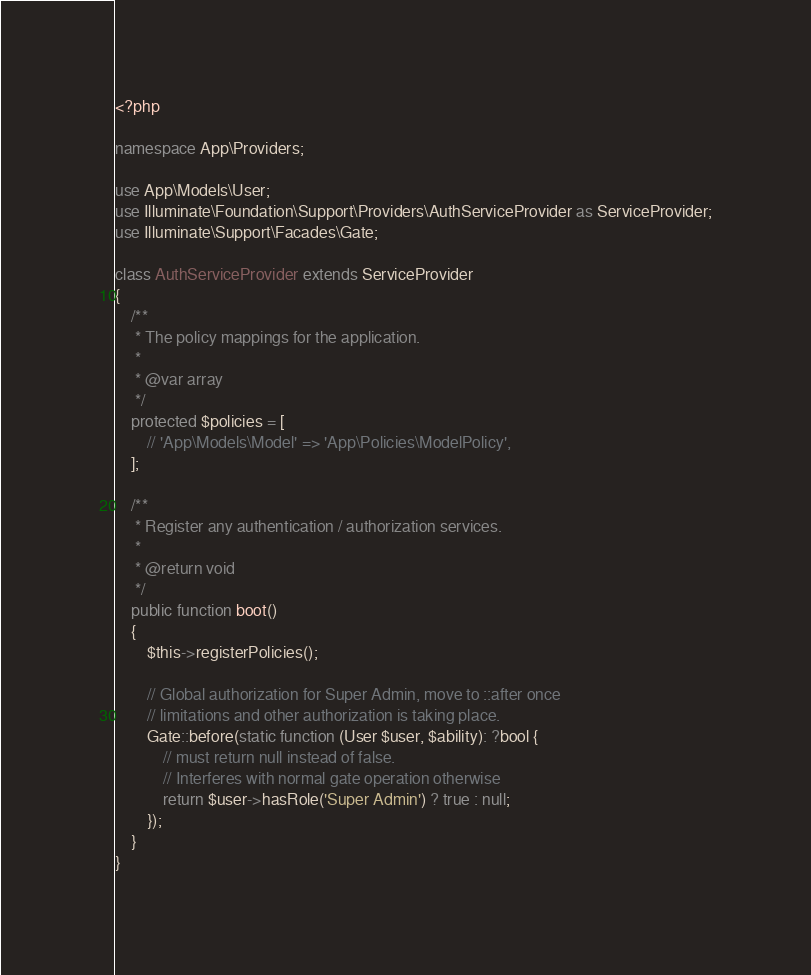<code> <loc_0><loc_0><loc_500><loc_500><_PHP_><?php

namespace App\Providers;

use App\Models\User;
use Illuminate\Foundation\Support\Providers\AuthServiceProvider as ServiceProvider;
use Illuminate\Support\Facades\Gate;

class AuthServiceProvider extends ServiceProvider
{
    /**
     * The policy mappings for the application.
     *
     * @var array
     */
    protected $policies = [
        // 'App\Models\Model' => 'App\Policies\ModelPolicy',
    ];

    /**
     * Register any authentication / authorization services.
     *
     * @return void
     */
    public function boot()
    {
        $this->registerPolicies();

        // Global authorization for Super Admin, move to ::after once
        // limitations and other authorization is taking place.
        Gate::before(static function (User $user, $ability): ?bool {
            // must return null instead of false. 
            // Interferes with normal gate operation otherwise
            return $user->hasRole('Super Admin') ? true : null;
        });
    }
}
</code> 